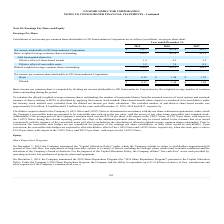According to On Semiconductor's financial document, How is Basic income per common share computed? dividing net income attributable to ON Semiconductor Corporation by the weighted average number of common shares outstanding during the period.. The document states: "Basic income per common share is computed by dividing net income attributable to ON Semiconductor Corporation by the weighted average number of common..." Also, How much is the excluded number of anti-dilutive share-based awards for the year ended December 31, 2019? According to the financial document, 0.8 million. The relevant text states: "nti-dilutive share-based awards was approximately 0.8 million, 0.6 million and 0.2 million for the years ended December 31, 2019, 2018 and 2017, respectively...." Also, How much is the excluded number of anti-dilutive share-based awards for the year ended December 31, 2018? According to the financial document, 0.6 million. The relevant text states: "share-based awards was approximately 0.8 million, 0.6 million and 0.2 million for the years ended December 31, 2019, 2018 and 2017, respectively...." Also, can you calculate: What is the change in Net income attributable to ON Semiconductor Corporation from December 31, 2018 to 2019? Based on the calculation: 211.7-627.4, the result is -415.7 (in millions). This is based on the information: "me attributable to ON Semiconductor Corporation $ 211.7 $ 627.4 $ 810.7 butable to ON Semiconductor Corporation $ 211.7 $ 627.4 $ 810.7..." The key data points involved are: 211.7, 627.4. Also, can you calculate: What is the change in Basic weighted average common shares outstanding from year ended December 31, 2018 to 2019? Based on the calculation: 410.9-423.8, the result is -12.9 (in millions). This is based on the information: "weighted average common shares outstanding 410.9 423.8 421.9 Basic weighted average common shares outstanding 410.9 423.8 421.9..." The key data points involved are: 410.9, 423.8. Also, can you calculate: What is the average Net income attributable to ON Semiconductor Corporation for December 31, 2018 to 2019? To answer this question, I need to perform calculations using the financial data. The calculation is: (211.7+627.4) / 2, which equals 419.55 (in millions). This is based on the information: "me attributable to ON Semiconductor Corporation $ 211.7 $ 627.4 $ 810.7 butable to ON Semiconductor Corporation $ 211.7 $ 627.4 $ 810.7..." The key data points involved are: 211.7, 627.4. 